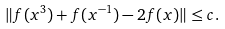Convert formula to latex. <formula><loc_0><loc_0><loc_500><loc_500>\| f ( x ^ { 3 } ) + f ( x ^ { - 1 } ) - 2 f ( x ) \| \leq c .</formula> 